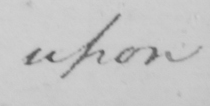Please provide the text content of this handwritten line. upon 